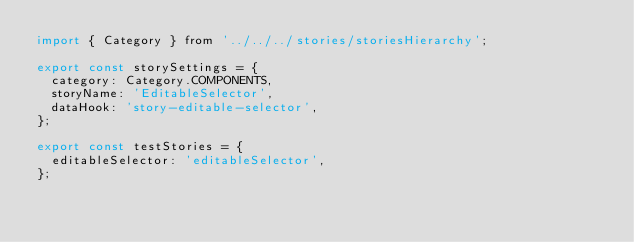Convert code to text. <code><loc_0><loc_0><loc_500><loc_500><_JavaScript_>import { Category } from '../../../stories/storiesHierarchy';

export const storySettings = {
  category: Category.COMPONENTS,
  storyName: 'EditableSelector',
  dataHook: 'story-editable-selector',
};

export const testStories = {
  editableSelector: 'editableSelector',
};
</code> 